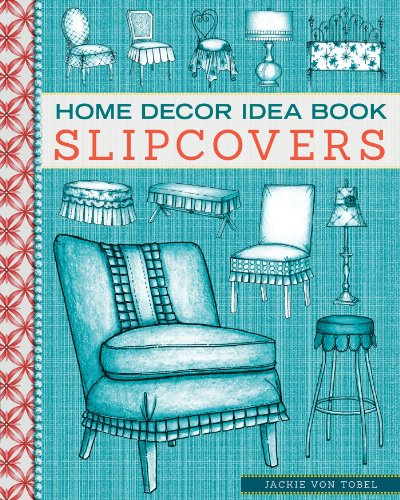Can you describe the style of artwork used on the book cover? The cover features detailed line drawings of various chair designs, depicting traditional chair styles with decorative slipcovers and upholstery details. The artwork is rendered in a distinctive, meticulously detailed style that emphasizes the textural aspects of the fabrics. 